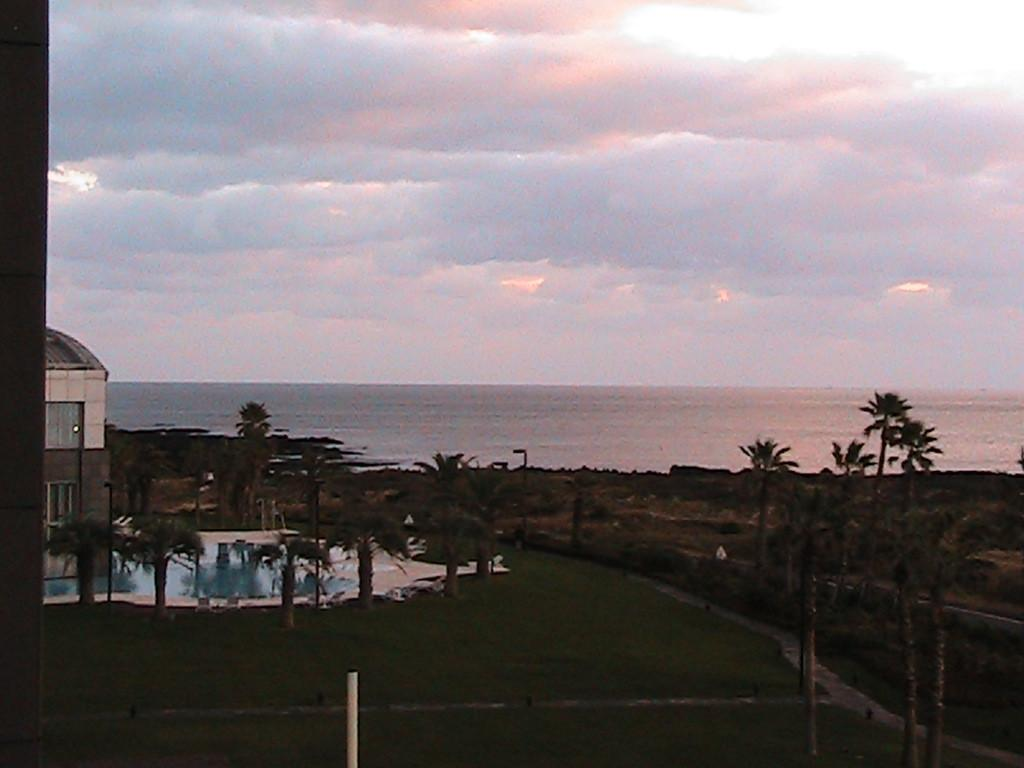What type of structures can be seen in the image? There are buildings in the image. What natural elements are present in the image? There are trees and grass visible in the image. What man-made objects can be seen in the image? There are poles in the image. What is visible at the top of the image? The sky is visible at the top of the image, and there are clouds in the sky. What is visible at the bottom of the image? There is water and grass visible at the bottom of the image. How many crows are sitting on the transport in the image? There are no crows or transport present in the image. What type of truck can be seen driving through the grass in the image? There is no truck visible in the image; it features buildings, trees, poles, sky, clouds, water, and grass. 